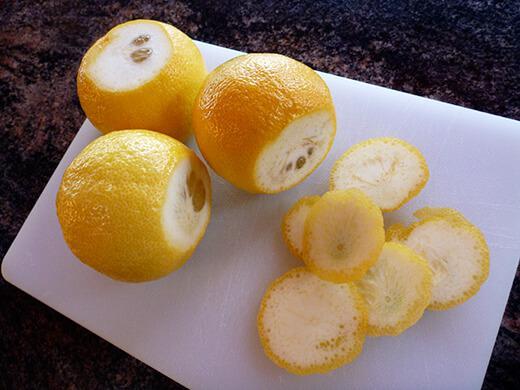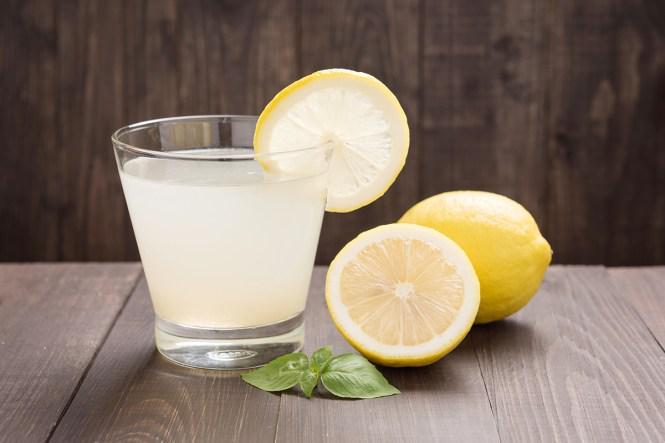The first image is the image on the left, the second image is the image on the right. For the images displayed, is the sentence "One image shows multiple lemons still on their tree, while the other image shows multiple lemons that have been picked from the tree but still have a few leaves with them." factually correct? Answer yes or no. No. 